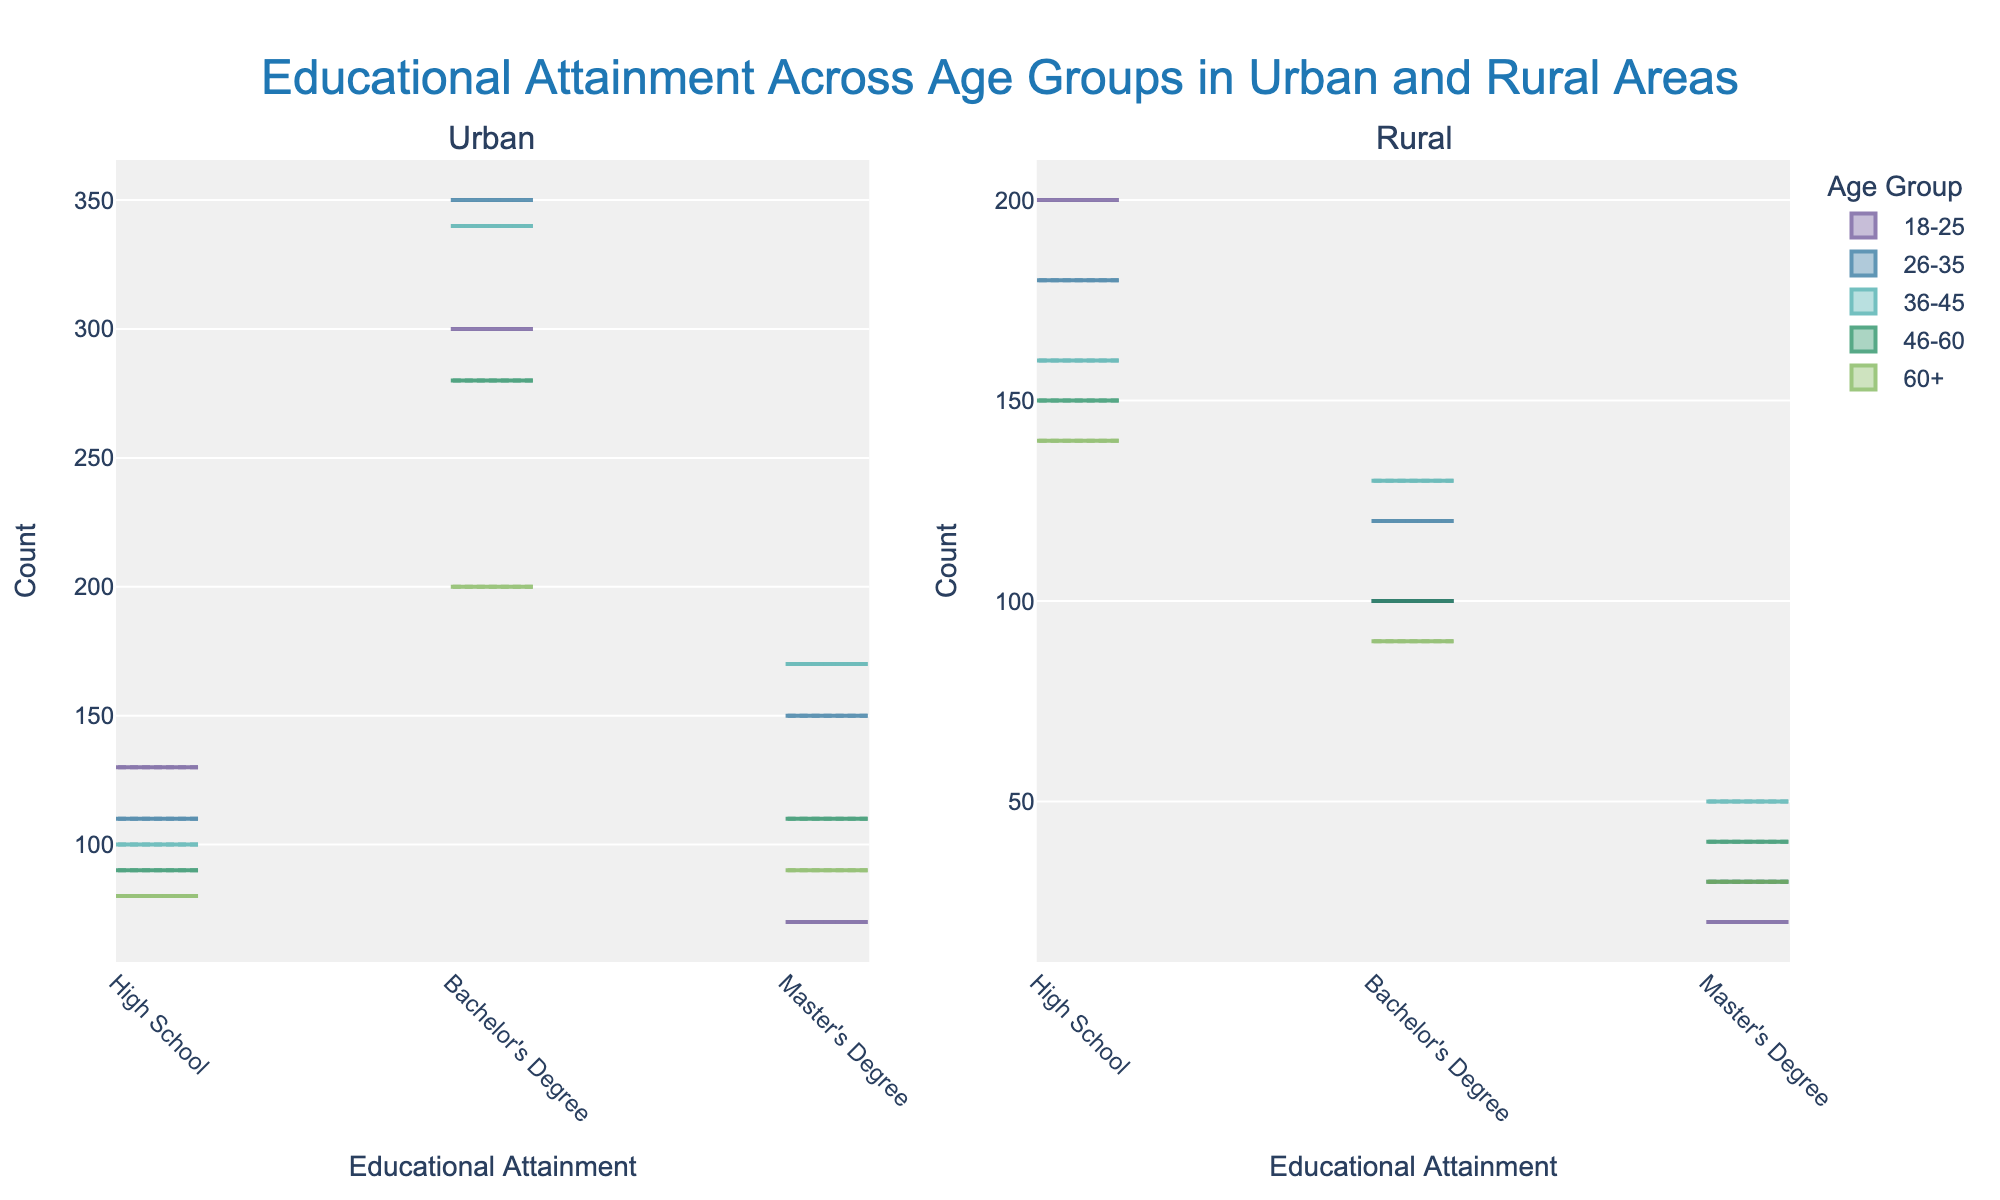What's the title of the plot? The title is usually presented at the top center of the plot area. Here, the title is easily visible above the subplots.
Answer: Educational Attainment Across Age Groups in Urban and Rural Areas How many subplots does the figure have? The figure consists of two distinct subplot regions side-by-side. One is labeled 'Urban', and the other is labeled 'Rural'.
Answer: Two Which age group in the Urban area shows the highest count for Bachelor's Degrees? By inspecting the Urban subplot closely, the age group with a violin shape extending the highest on the 'Bachelor's Degree' label represents the highest count. This is seen at the 26-35 age group in the Urban area.
Answer: 26-35 Compare the number of Master’s Degree holders in Urban and Rural areas within the age group of 46-60. Which area has more count? Checking the two subplots for the age group 46-60, the Urban subplot has a violin plot higher on the 'Master's Degree' axis compared to the Rural. This shows a higher count in Urban.
Answer: Urban What is the trend of high school counts across different age groups in Urban areas? Observing the Urban subplot, the height of violin plots on the 'High School' axis decreases as the age group moves from 18-25 to 60+.
Answer: Declining trend Which location has a greater variability in educational attainment for the age group 36-45? Compare the spread and shape of the violins for both Urban and Rural in the 36-45 age group. The Urban area shows broader distribution across educational categories, indicating greater variability.
Answer: Urban For which Educational Attainment level is the Urban and Rural count closest in the age group 18-25? Compare the heights of the violins in Urban and Rural subplots within the 18-25 age group across all educational levels. The counts for 'Master's Degree' level are closest.
Answer: Master's Degree Does the count of Bachelor's Degree in Rural areas increase or decrease with age? Observing the Rural subplot, the heights of the violins representing 'Bachelor's Degree' from 18-25, 26-35, 36-45, 46-60, and 60+ suggest the trend. It decreases as age increases.
Answer: Decrease Which age group has the smallest count for High School level in the Rural area? Check the Rural subplot and identify the shortest violin on the 'High School' axis. It occurs in the 60+ age group.
Answer: 60+ 